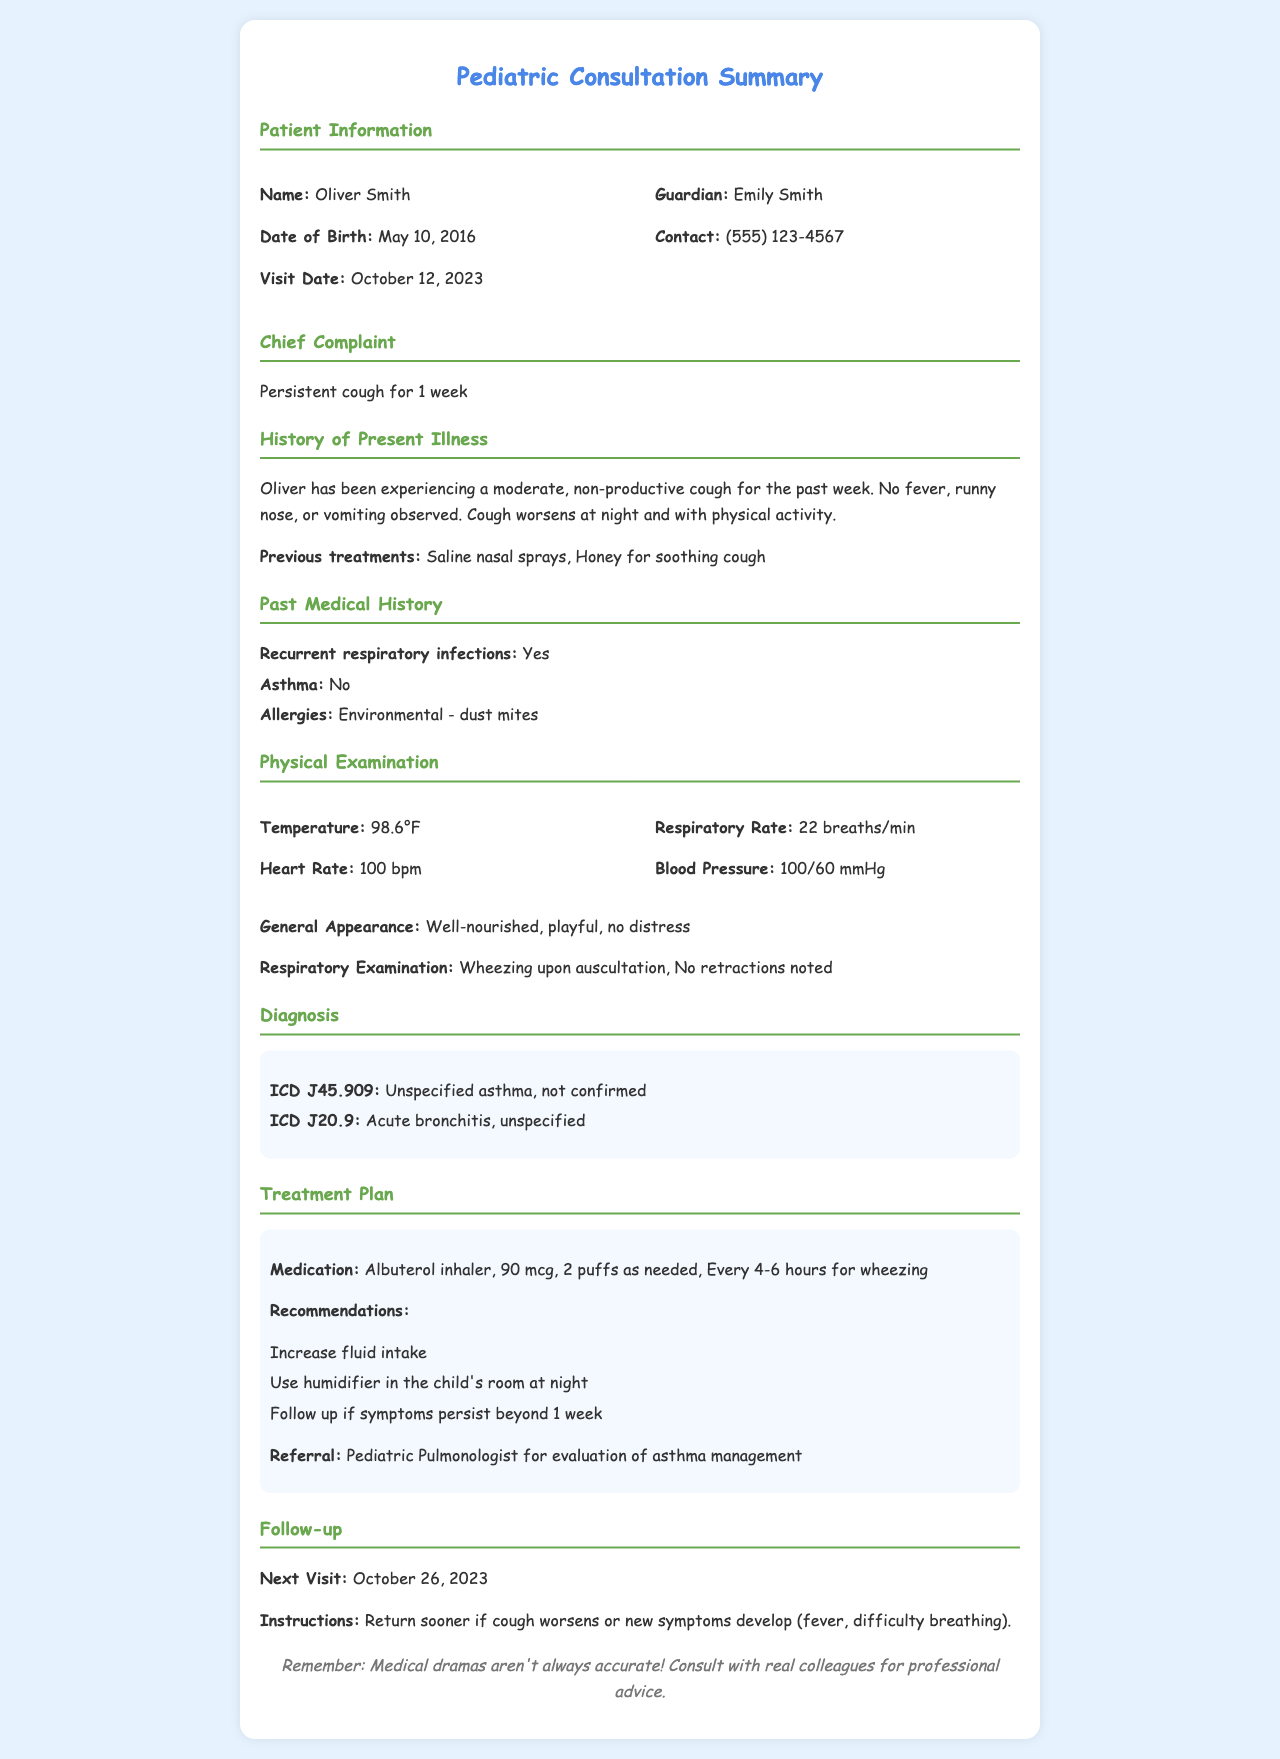what is the patient's name? The patient's name is displayed in the patient information section of the document.
Answer: Oliver Smith what is the date of birth of the patient? The date of birth can be found in the patient information section.
Answer: May 10, 2016 what was the chief complaint during this visit? The chief complaint is listed under the Chief Complaint heading.
Answer: Persistent cough for 1 week how many breaths per minute was the respiratory rate? The respiratory rate is noted in the physical examination section.
Answer: 22 breaths/min what are the diagnoses for this patient? The diagnoses are listed under the Diagnosis section, requiring retrieval of multiple items.
Answer: Unspecified asthma, not confirmed and Acute bronchitis, unspecified what medication was prescribed? The medication is specified in the Treatment Plan section under Medication.
Answer: Albuterol inhaler how often should the albuterol inhaler be used? This frequency is mentioned in the Treatment Plan section concerning medication use.
Answer: Every 4-6 hours who is the guardian of the patient? The guardian's name can be found in the patient information section.
Answer: Emily Smith what is the follow-up date for the next visit? The next visit date can be retrieved from the Follow-up section of the document.
Answer: October 26, 2023 what is the recommendation regarding fluid intake? The recommendation is listed under the Treatment Plan section.
Answer: Increase fluid intake 